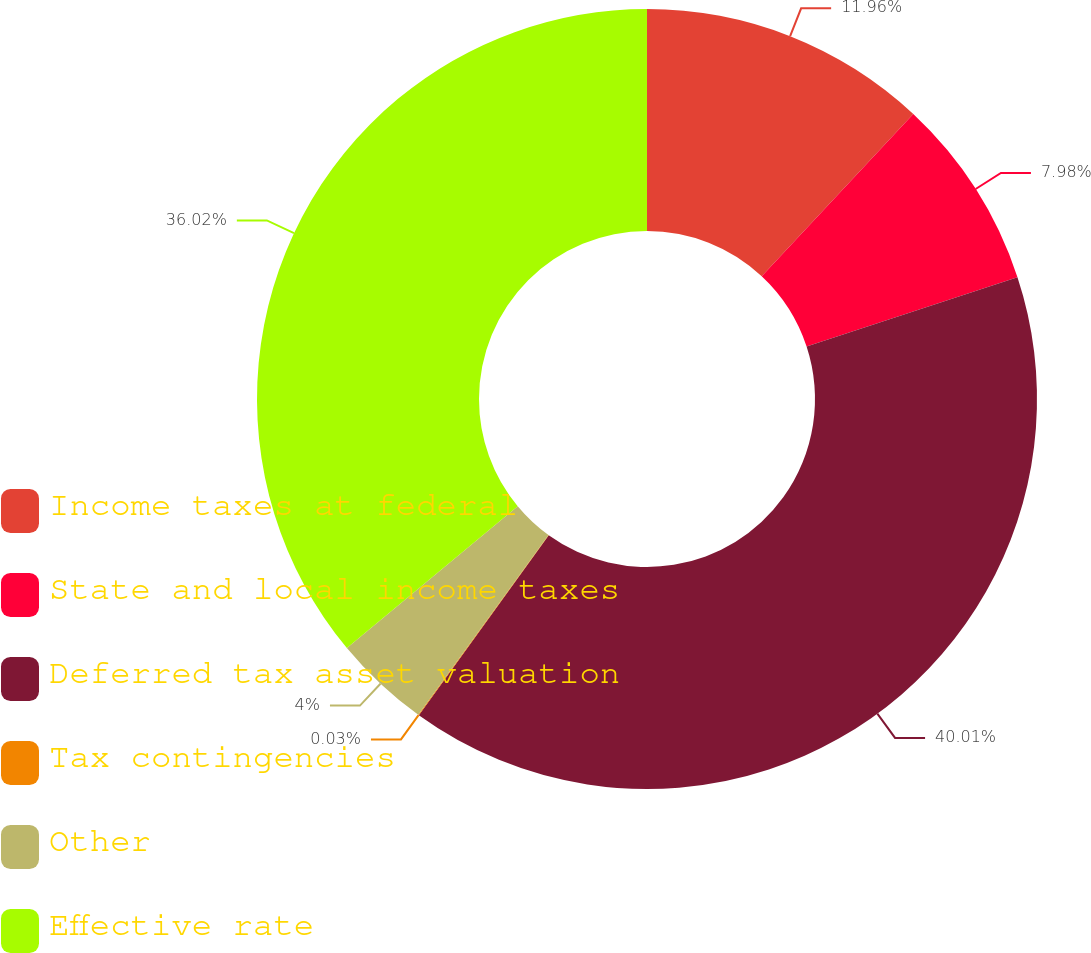Convert chart to OTSL. <chart><loc_0><loc_0><loc_500><loc_500><pie_chart><fcel>Income taxes at federal<fcel>State and local income taxes<fcel>Deferred tax asset valuation<fcel>Tax contingencies<fcel>Other<fcel>Effective rate<nl><fcel>11.96%<fcel>7.98%<fcel>40.0%<fcel>0.03%<fcel>4.0%<fcel>36.02%<nl></chart> 